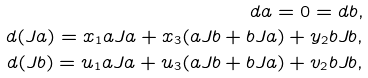Convert formula to latex. <formula><loc_0><loc_0><loc_500><loc_500>d a = 0 = d b , \\ d ( J a ) = x _ { 1 } a J a + x _ { 3 } ( a J b + b J a ) + y _ { 2 } b J b , \\ d ( J b ) = u _ { 1 } a J a + u _ { 3 } ( a J b + b J a ) + v _ { 2 } b J b ,</formula> 